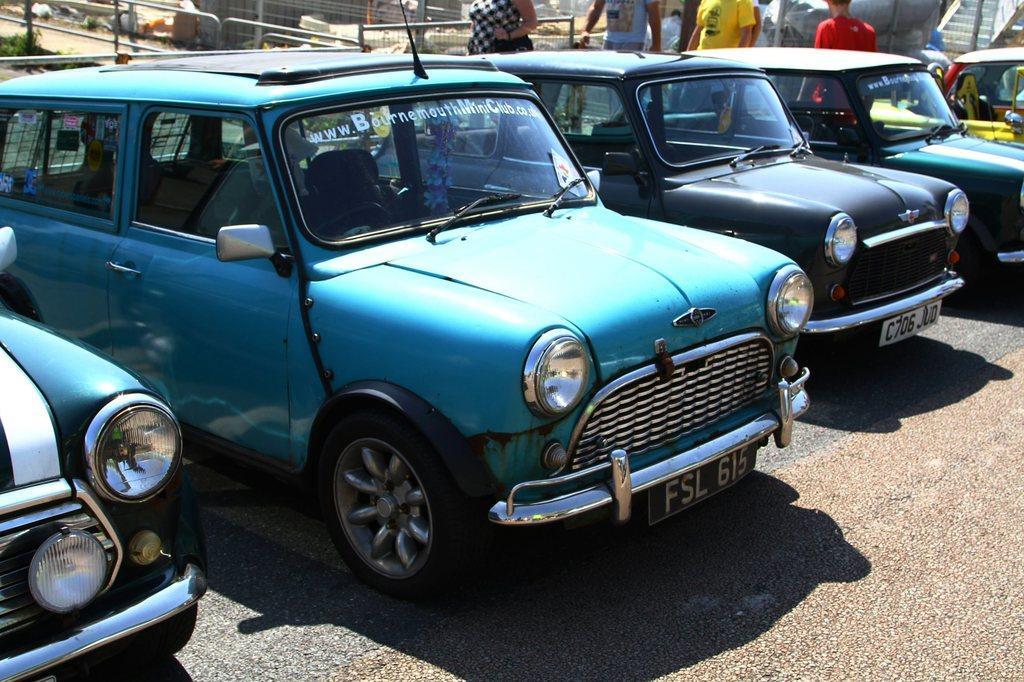Can you describe this image briefly? In this image we can see motor vehicles on the road, person's standing on the road, shrubs and fences. 